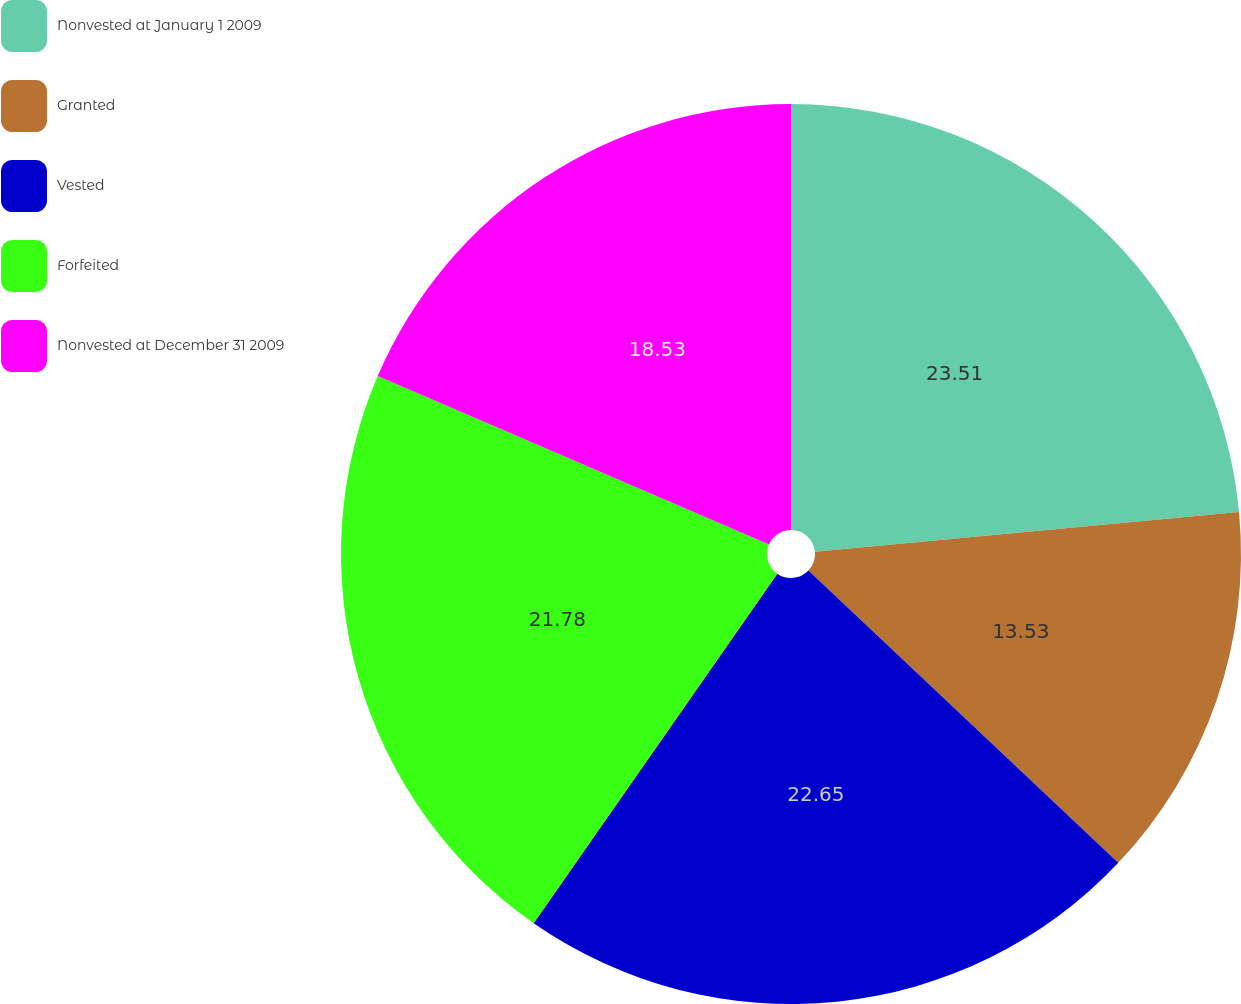Convert chart. <chart><loc_0><loc_0><loc_500><loc_500><pie_chart><fcel>Nonvested at January 1 2009<fcel>Granted<fcel>Vested<fcel>Forfeited<fcel>Nonvested at December 31 2009<nl><fcel>23.51%<fcel>13.53%<fcel>22.65%<fcel>21.78%<fcel>18.53%<nl></chart> 